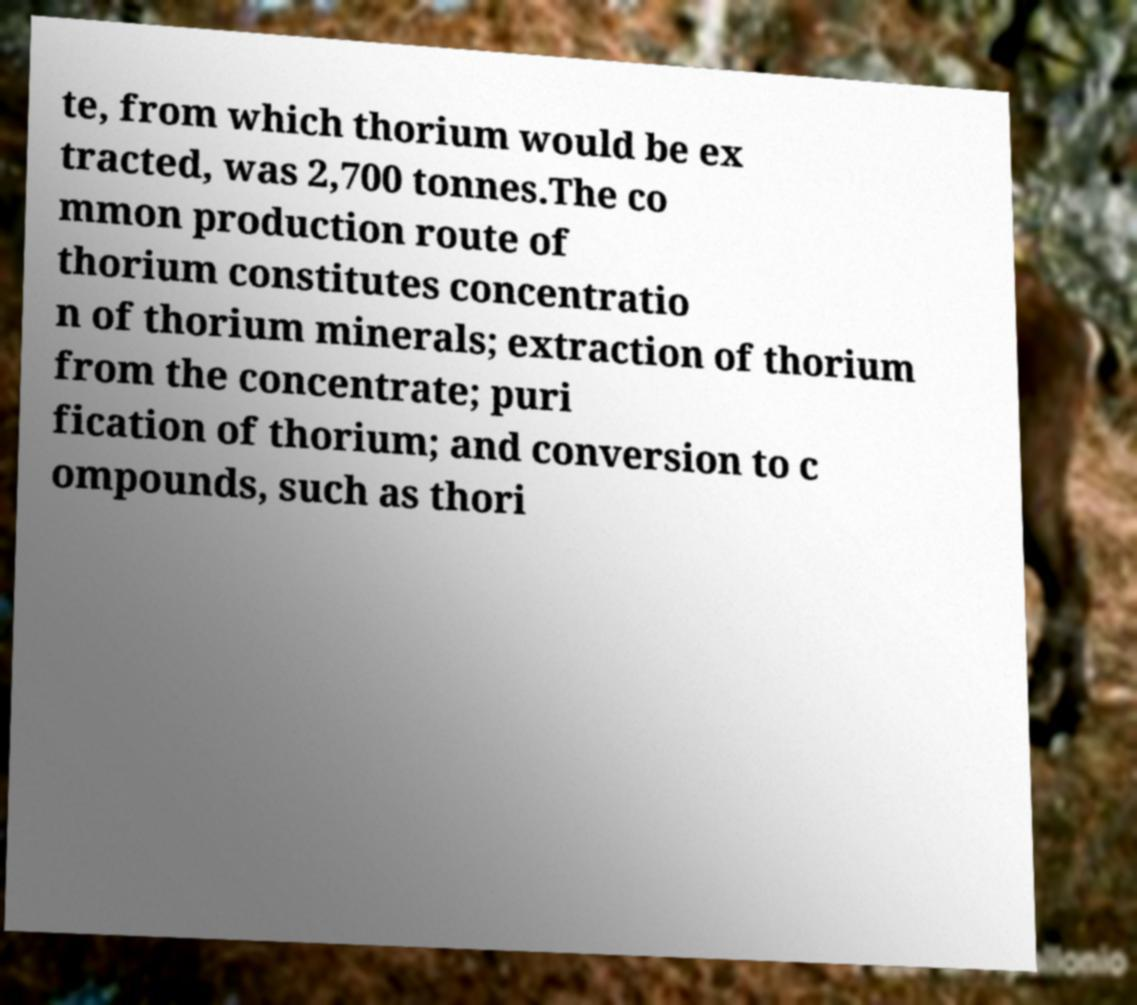Could you assist in decoding the text presented in this image and type it out clearly? te, from which thorium would be ex tracted, was 2,700 tonnes.The co mmon production route of thorium constitutes concentratio n of thorium minerals; extraction of thorium from the concentrate; puri fication of thorium; and conversion to c ompounds, such as thori 